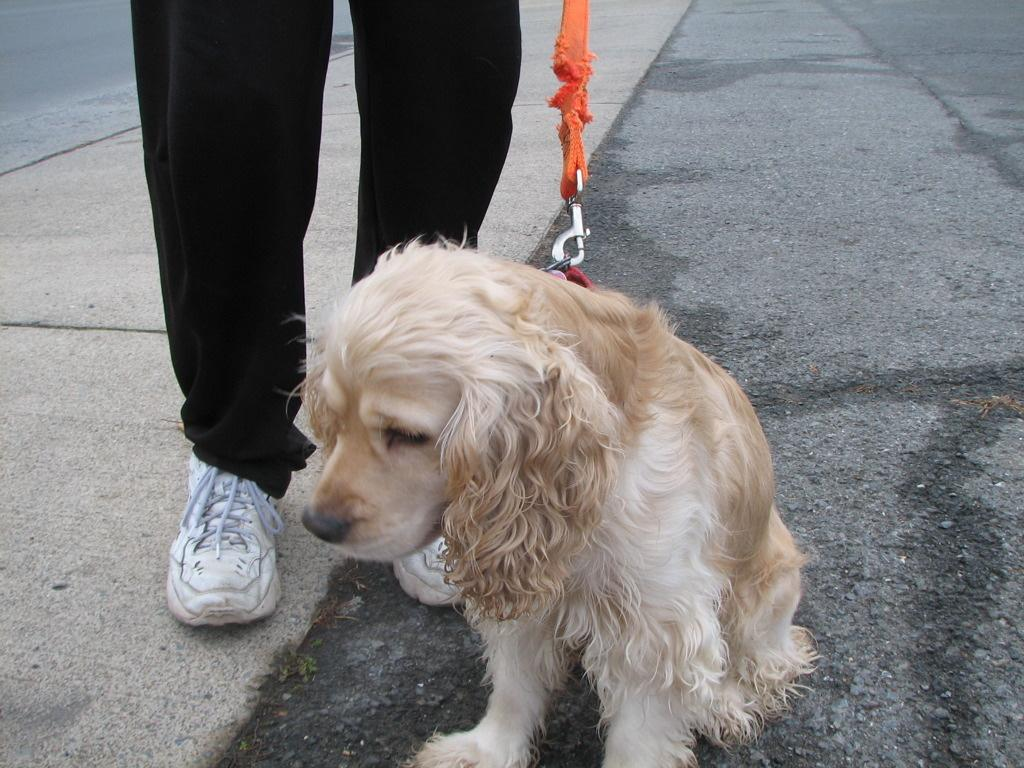What type of animal is in the image? There is a dog in the image. How is the dog being controlled or restrained? The dog has a leash tied to it. Can you see any part of a person in the image? Yes, there are legs of a person visible behind the dog. What is the setting or environment in the image? There is a path in the image. What type of canvas is the dog sitting on in the image? There is no canvas present in the image; it is a dog on a path with a leash and a person nearby. 